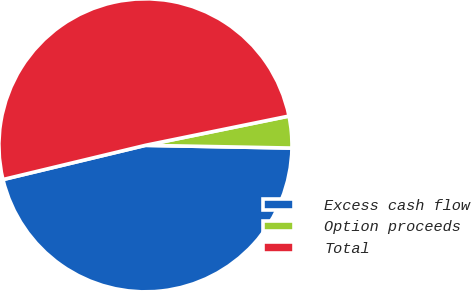<chart> <loc_0><loc_0><loc_500><loc_500><pie_chart><fcel>Excess cash flow<fcel>Option proceeds<fcel>Total<nl><fcel>45.95%<fcel>3.5%<fcel>50.55%<nl></chart> 